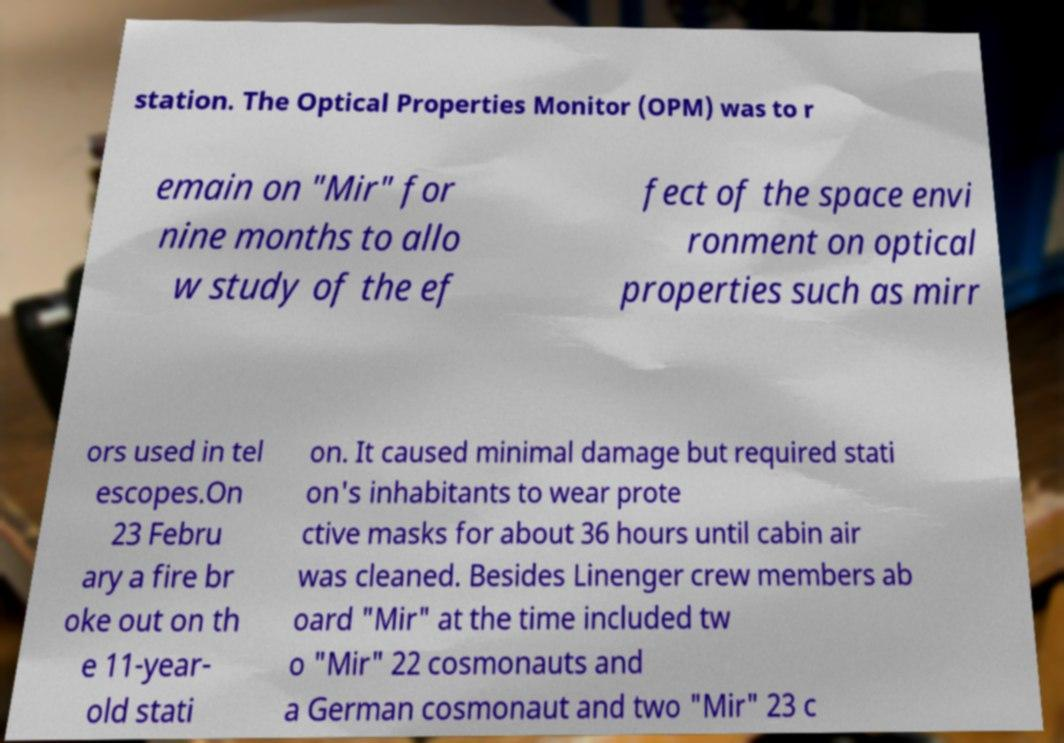Please read and relay the text visible in this image. What does it say? station. The Optical Properties Monitor (OPM) was to r emain on "Mir" for nine months to allo w study of the ef fect of the space envi ronment on optical properties such as mirr ors used in tel escopes.On 23 Febru ary a fire br oke out on th e 11-year- old stati on. It caused minimal damage but required stati on's inhabitants to wear prote ctive masks for about 36 hours until cabin air was cleaned. Besides Linenger crew members ab oard "Mir" at the time included tw o "Mir" 22 cosmonauts and a German cosmonaut and two "Mir" 23 c 